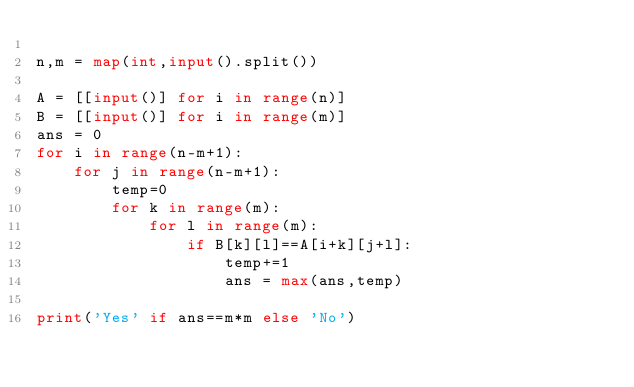<code> <loc_0><loc_0><loc_500><loc_500><_Python_>
n,m = map(int,input().split())

A = [[input()] for i in range(n)]
B = [[input()] for i in range(m)]
ans = 0
for i in range(n-m+1):
    for j in range(n-m+1):
        temp=0
        for k in range(m):
            for l in range(m):
                if B[k][l]==A[i+k][j+l]:
                    temp+=1
                    ans = max(ans,temp)
                                    
print('Yes' if ans==m*m else 'No')</code> 